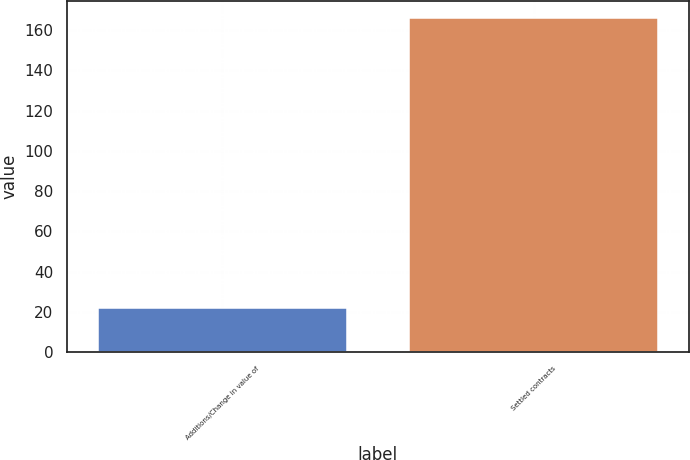Convert chart. <chart><loc_0><loc_0><loc_500><loc_500><bar_chart><fcel>Additions/Change in value of<fcel>Settled contracts<nl><fcel>22<fcel>166<nl></chart> 